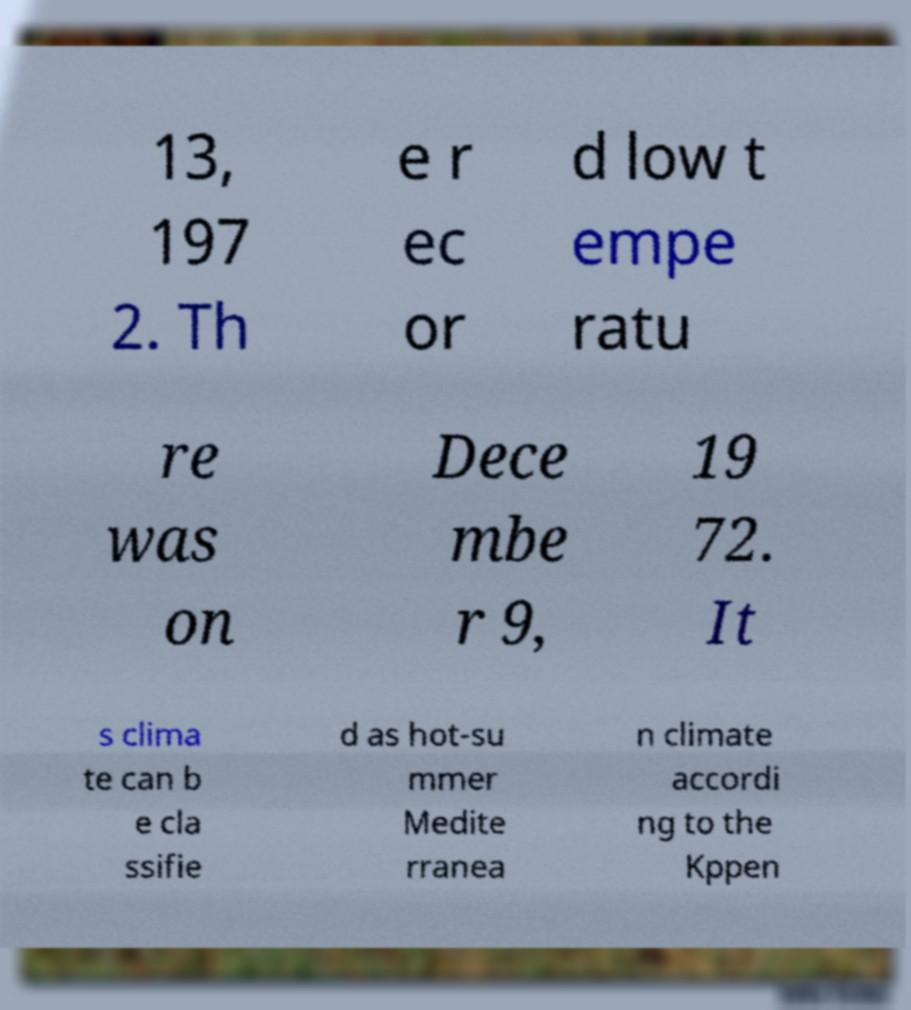There's text embedded in this image that I need extracted. Can you transcribe it verbatim? 13, 197 2. Th e r ec or d low t empe ratu re was on Dece mbe r 9, 19 72. It s clima te can b e cla ssifie d as hot-su mmer Medite rranea n climate accordi ng to the Kppen 